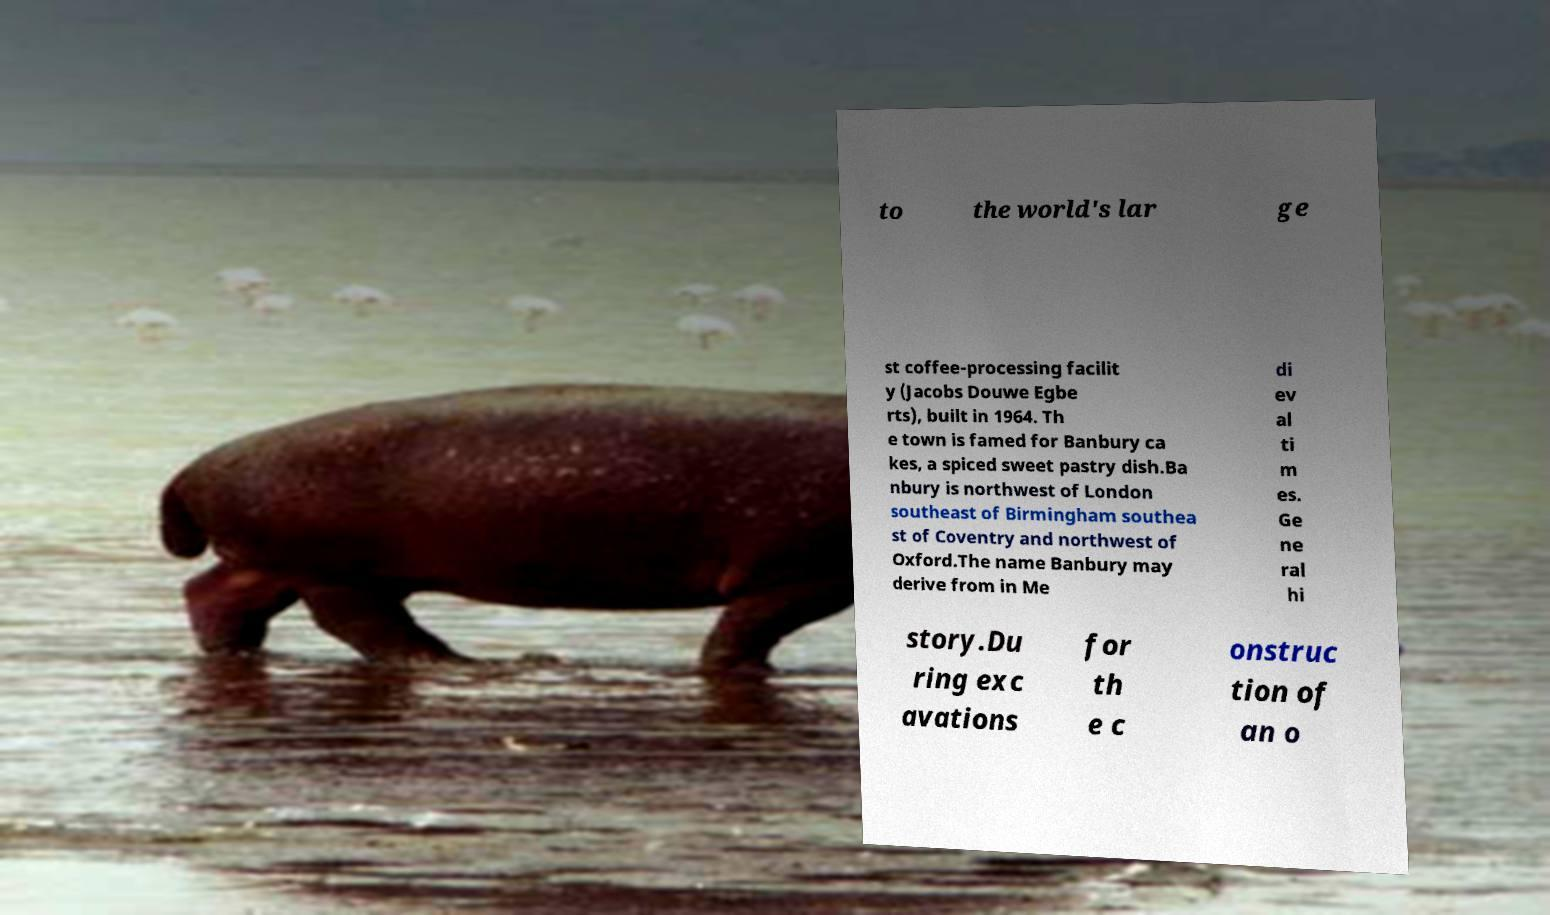For documentation purposes, I need the text within this image transcribed. Could you provide that? to the world's lar ge st coffee-processing facilit y (Jacobs Douwe Egbe rts), built in 1964. Th e town is famed for Banbury ca kes, a spiced sweet pastry dish.Ba nbury is northwest of London southeast of Birmingham southea st of Coventry and northwest of Oxford.The name Banbury may derive from in Me di ev al ti m es. Ge ne ral hi story.Du ring exc avations for th e c onstruc tion of an o 